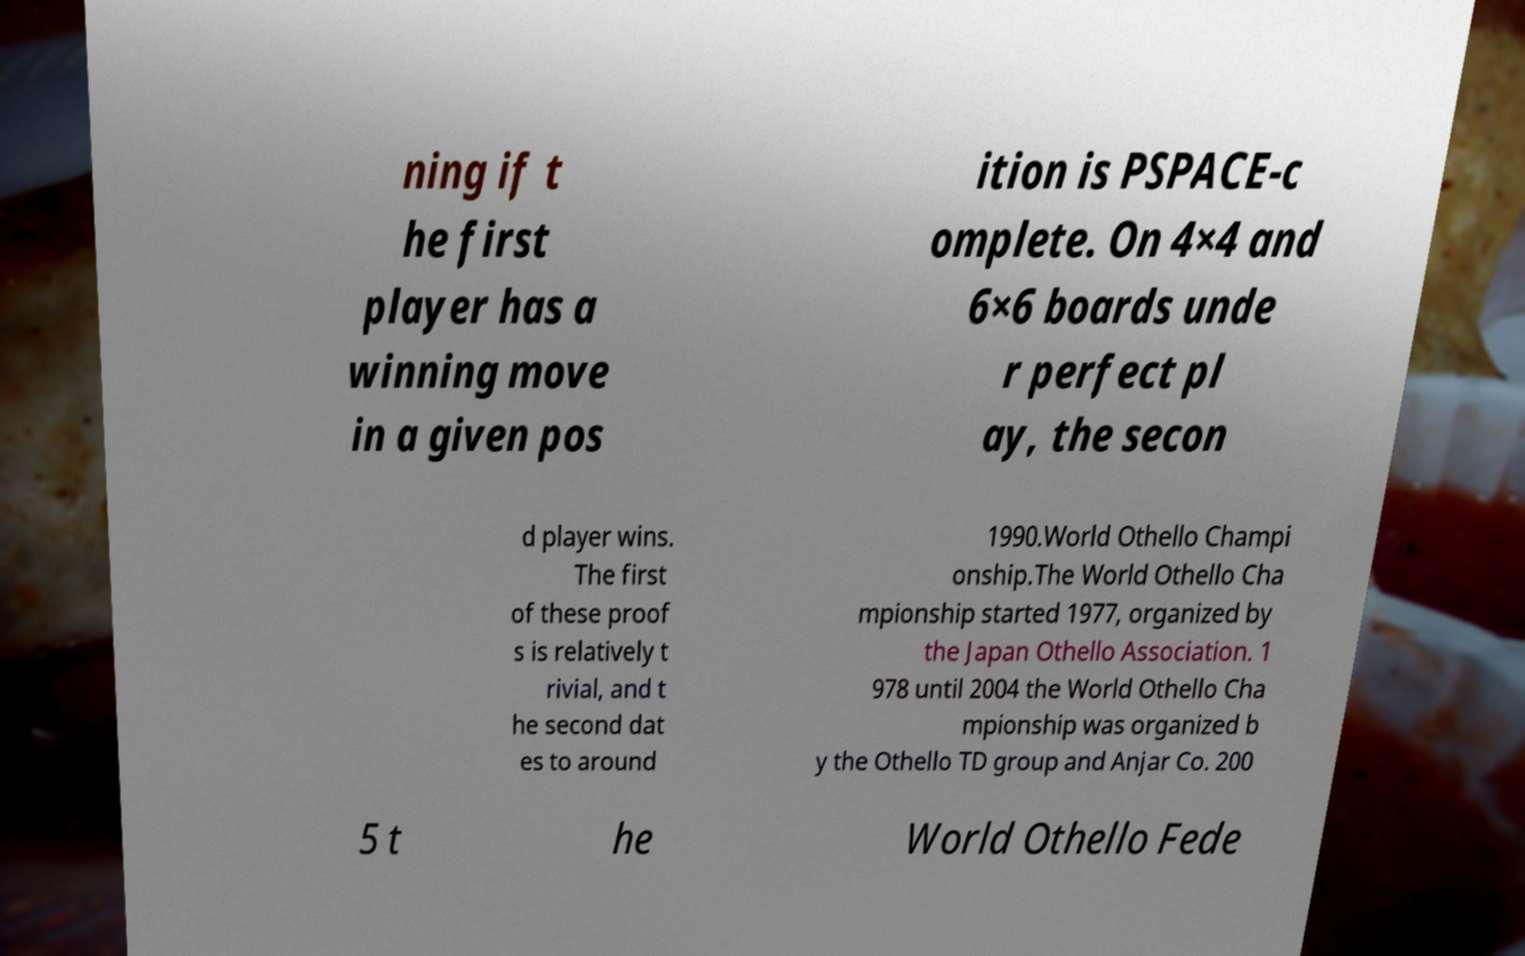Can you read and provide the text displayed in the image?This photo seems to have some interesting text. Can you extract and type it out for me? ning if t he first player has a winning move in a given pos ition is PSPACE-c omplete. On 4×4 and 6×6 boards unde r perfect pl ay, the secon d player wins. The first of these proof s is relatively t rivial, and t he second dat es to around 1990.World Othello Champi onship.The World Othello Cha mpionship started 1977, organized by the Japan Othello Association. 1 978 until 2004 the World Othello Cha mpionship was organized b y the Othello TD group and Anjar Co. 200 5 t he World Othello Fede 